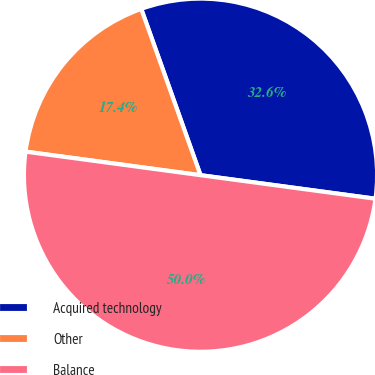Convert chart. <chart><loc_0><loc_0><loc_500><loc_500><pie_chart><fcel>Acquired technology<fcel>Other<fcel>Balance<nl><fcel>32.58%<fcel>17.42%<fcel>50.0%<nl></chart> 